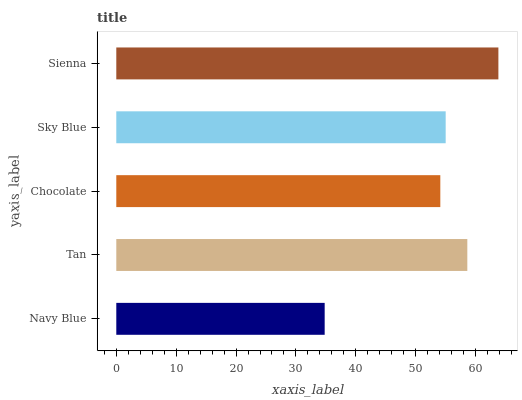Is Navy Blue the minimum?
Answer yes or no. Yes. Is Sienna the maximum?
Answer yes or no. Yes. Is Tan the minimum?
Answer yes or no. No. Is Tan the maximum?
Answer yes or no. No. Is Tan greater than Navy Blue?
Answer yes or no. Yes. Is Navy Blue less than Tan?
Answer yes or no. Yes. Is Navy Blue greater than Tan?
Answer yes or no. No. Is Tan less than Navy Blue?
Answer yes or no. No. Is Sky Blue the high median?
Answer yes or no. Yes. Is Sky Blue the low median?
Answer yes or no. Yes. Is Navy Blue the high median?
Answer yes or no. No. Is Tan the low median?
Answer yes or no. No. 